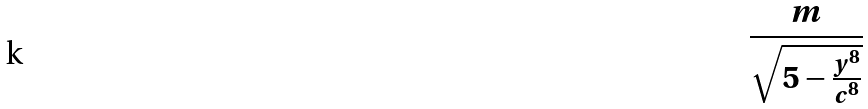<formula> <loc_0><loc_0><loc_500><loc_500>\frac { m } { \sqrt { 5 - \frac { y ^ { 8 } } { c ^ { 8 } } } }</formula> 